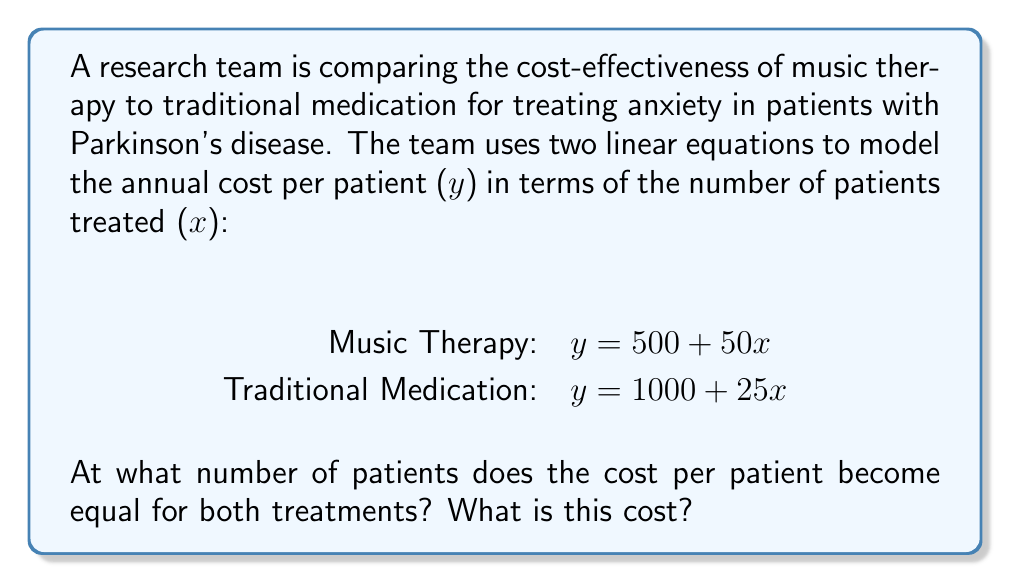Teach me how to tackle this problem. To solve this problem, we need to find the point where the two equations intersect. This represents the number of patients at which the cost per patient is equal for both treatments.

Step 1: Set up the equation
$$500 + 50x = 1000 + 25x$$

Step 2: Solve for x
$$500 + 50x = 1000 + 25x$$
$$50x - 25x = 1000 - 500$$
$$25x = 500$$
$$x = 20$$

Step 3: Calculate the cost at this point by substituting x = 20 into either equation
Using the Music Therapy equation:
$$y = 500 + 50(20) = 500 + 1000 = 1500$$

Therefore, the cost per patient becomes equal for both treatments when 20 patients are treated, and the cost at this point is $1500 per patient.
Answer: 20 patients; $1500 per patient 